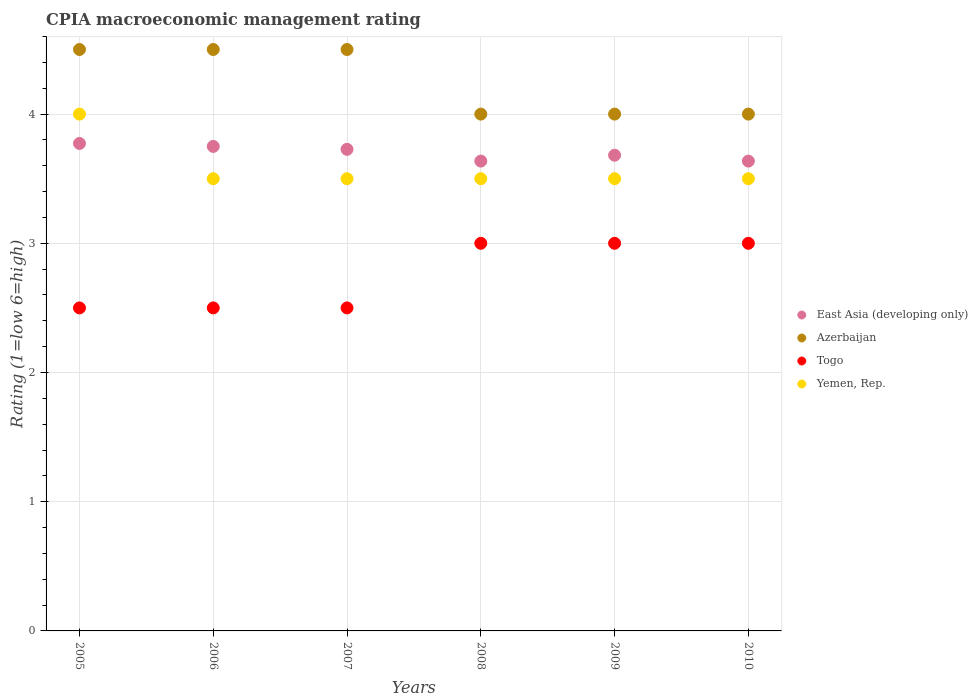How many different coloured dotlines are there?
Make the answer very short. 4. Is the number of dotlines equal to the number of legend labels?
Give a very brief answer. Yes. What is the CPIA rating in Togo in 2010?
Ensure brevity in your answer.  3. Across all years, what is the maximum CPIA rating in East Asia (developing only)?
Ensure brevity in your answer.  3.77. Across all years, what is the minimum CPIA rating in East Asia (developing only)?
Your answer should be very brief. 3.64. What is the average CPIA rating in Togo per year?
Ensure brevity in your answer.  2.75. In the year 2007, what is the difference between the CPIA rating in East Asia (developing only) and CPIA rating in Yemen, Rep.?
Your answer should be very brief. 0.23. What is the ratio of the CPIA rating in Yemen, Rep. in 2005 to that in 2006?
Provide a short and direct response. 1.14. Is the CPIA rating in East Asia (developing only) in 2006 less than that in 2007?
Make the answer very short. No. Is it the case that in every year, the sum of the CPIA rating in Azerbaijan and CPIA rating in Yemen, Rep.  is greater than the CPIA rating in Togo?
Offer a very short reply. Yes. Does the CPIA rating in Yemen, Rep. monotonically increase over the years?
Provide a short and direct response. No. Is the CPIA rating in East Asia (developing only) strictly less than the CPIA rating in Yemen, Rep. over the years?
Provide a succinct answer. No. How many years are there in the graph?
Your response must be concise. 6. What is the difference between two consecutive major ticks on the Y-axis?
Ensure brevity in your answer.  1. Does the graph contain any zero values?
Your answer should be very brief. No. Does the graph contain grids?
Your answer should be compact. Yes. How many legend labels are there?
Keep it short and to the point. 4. How are the legend labels stacked?
Ensure brevity in your answer.  Vertical. What is the title of the graph?
Offer a very short reply. CPIA macroeconomic management rating. What is the label or title of the X-axis?
Your answer should be very brief. Years. What is the Rating (1=low 6=high) of East Asia (developing only) in 2005?
Your answer should be compact. 3.77. What is the Rating (1=low 6=high) of Togo in 2005?
Your response must be concise. 2.5. What is the Rating (1=low 6=high) of East Asia (developing only) in 2006?
Offer a very short reply. 3.75. What is the Rating (1=low 6=high) of Azerbaijan in 2006?
Give a very brief answer. 4.5. What is the Rating (1=low 6=high) in Togo in 2006?
Make the answer very short. 2.5. What is the Rating (1=low 6=high) in East Asia (developing only) in 2007?
Your answer should be compact. 3.73. What is the Rating (1=low 6=high) in Togo in 2007?
Ensure brevity in your answer.  2.5. What is the Rating (1=low 6=high) in Yemen, Rep. in 2007?
Your response must be concise. 3.5. What is the Rating (1=low 6=high) of East Asia (developing only) in 2008?
Your answer should be compact. 3.64. What is the Rating (1=low 6=high) in Togo in 2008?
Provide a succinct answer. 3. What is the Rating (1=low 6=high) of Yemen, Rep. in 2008?
Provide a short and direct response. 3.5. What is the Rating (1=low 6=high) of East Asia (developing only) in 2009?
Provide a succinct answer. 3.68. What is the Rating (1=low 6=high) of Togo in 2009?
Offer a very short reply. 3. What is the Rating (1=low 6=high) in Yemen, Rep. in 2009?
Your response must be concise. 3.5. What is the Rating (1=low 6=high) in East Asia (developing only) in 2010?
Offer a very short reply. 3.64. What is the Rating (1=low 6=high) in Azerbaijan in 2010?
Give a very brief answer. 4. What is the Rating (1=low 6=high) of Togo in 2010?
Your answer should be very brief. 3. What is the Rating (1=low 6=high) in Yemen, Rep. in 2010?
Keep it short and to the point. 3.5. Across all years, what is the maximum Rating (1=low 6=high) of East Asia (developing only)?
Your answer should be compact. 3.77. Across all years, what is the maximum Rating (1=low 6=high) of Azerbaijan?
Your answer should be compact. 4.5. Across all years, what is the maximum Rating (1=low 6=high) of Togo?
Make the answer very short. 3. Across all years, what is the minimum Rating (1=low 6=high) in East Asia (developing only)?
Provide a short and direct response. 3.64. Across all years, what is the minimum Rating (1=low 6=high) of Togo?
Offer a terse response. 2.5. What is the total Rating (1=low 6=high) in East Asia (developing only) in the graph?
Make the answer very short. 22.2. What is the total Rating (1=low 6=high) in Azerbaijan in the graph?
Provide a succinct answer. 25.5. What is the total Rating (1=low 6=high) of Togo in the graph?
Your response must be concise. 16.5. What is the total Rating (1=low 6=high) in Yemen, Rep. in the graph?
Give a very brief answer. 21.5. What is the difference between the Rating (1=low 6=high) of East Asia (developing only) in 2005 and that in 2006?
Your answer should be very brief. 0.02. What is the difference between the Rating (1=low 6=high) in Togo in 2005 and that in 2006?
Offer a very short reply. 0. What is the difference between the Rating (1=low 6=high) in East Asia (developing only) in 2005 and that in 2007?
Keep it short and to the point. 0.05. What is the difference between the Rating (1=low 6=high) in Azerbaijan in 2005 and that in 2007?
Make the answer very short. 0. What is the difference between the Rating (1=low 6=high) of East Asia (developing only) in 2005 and that in 2008?
Offer a very short reply. 0.14. What is the difference between the Rating (1=low 6=high) in Azerbaijan in 2005 and that in 2008?
Your answer should be very brief. 0.5. What is the difference between the Rating (1=low 6=high) of East Asia (developing only) in 2005 and that in 2009?
Your answer should be compact. 0.09. What is the difference between the Rating (1=low 6=high) of Azerbaijan in 2005 and that in 2009?
Ensure brevity in your answer.  0.5. What is the difference between the Rating (1=low 6=high) in East Asia (developing only) in 2005 and that in 2010?
Your answer should be very brief. 0.14. What is the difference between the Rating (1=low 6=high) in Yemen, Rep. in 2005 and that in 2010?
Ensure brevity in your answer.  0.5. What is the difference between the Rating (1=low 6=high) of East Asia (developing only) in 2006 and that in 2007?
Your answer should be compact. 0.02. What is the difference between the Rating (1=low 6=high) in Yemen, Rep. in 2006 and that in 2007?
Ensure brevity in your answer.  0. What is the difference between the Rating (1=low 6=high) in East Asia (developing only) in 2006 and that in 2008?
Your answer should be compact. 0.11. What is the difference between the Rating (1=low 6=high) in Azerbaijan in 2006 and that in 2008?
Your answer should be very brief. 0.5. What is the difference between the Rating (1=low 6=high) in Togo in 2006 and that in 2008?
Provide a short and direct response. -0.5. What is the difference between the Rating (1=low 6=high) of Yemen, Rep. in 2006 and that in 2008?
Give a very brief answer. 0. What is the difference between the Rating (1=low 6=high) in East Asia (developing only) in 2006 and that in 2009?
Your answer should be compact. 0.07. What is the difference between the Rating (1=low 6=high) in Azerbaijan in 2006 and that in 2009?
Keep it short and to the point. 0.5. What is the difference between the Rating (1=low 6=high) of East Asia (developing only) in 2006 and that in 2010?
Your answer should be very brief. 0.11. What is the difference between the Rating (1=low 6=high) in Yemen, Rep. in 2006 and that in 2010?
Offer a very short reply. 0. What is the difference between the Rating (1=low 6=high) of East Asia (developing only) in 2007 and that in 2008?
Offer a very short reply. 0.09. What is the difference between the Rating (1=low 6=high) in Yemen, Rep. in 2007 and that in 2008?
Your response must be concise. 0. What is the difference between the Rating (1=low 6=high) of East Asia (developing only) in 2007 and that in 2009?
Provide a succinct answer. 0.05. What is the difference between the Rating (1=low 6=high) in Azerbaijan in 2007 and that in 2009?
Your answer should be compact. 0.5. What is the difference between the Rating (1=low 6=high) of Yemen, Rep. in 2007 and that in 2009?
Offer a very short reply. 0. What is the difference between the Rating (1=low 6=high) of East Asia (developing only) in 2007 and that in 2010?
Provide a short and direct response. 0.09. What is the difference between the Rating (1=low 6=high) of Azerbaijan in 2007 and that in 2010?
Give a very brief answer. 0.5. What is the difference between the Rating (1=low 6=high) of Yemen, Rep. in 2007 and that in 2010?
Offer a terse response. 0. What is the difference between the Rating (1=low 6=high) in East Asia (developing only) in 2008 and that in 2009?
Your answer should be very brief. -0.05. What is the difference between the Rating (1=low 6=high) in Azerbaijan in 2008 and that in 2009?
Make the answer very short. 0. What is the difference between the Rating (1=low 6=high) in Yemen, Rep. in 2008 and that in 2009?
Provide a succinct answer. 0. What is the difference between the Rating (1=low 6=high) in East Asia (developing only) in 2008 and that in 2010?
Offer a very short reply. 0. What is the difference between the Rating (1=low 6=high) of Yemen, Rep. in 2008 and that in 2010?
Make the answer very short. 0. What is the difference between the Rating (1=low 6=high) in East Asia (developing only) in 2009 and that in 2010?
Give a very brief answer. 0.05. What is the difference between the Rating (1=low 6=high) in Azerbaijan in 2009 and that in 2010?
Offer a terse response. 0. What is the difference between the Rating (1=low 6=high) of East Asia (developing only) in 2005 and the Rating (1=low 6=high) of Azerbaijan in 2006?
Provide a succinct answer. -0.73. What is the difference between the Rating (1=low 6=high) of East Asia (developing only) in 2005 and the Rating (1=low 6=high) of Togo in 2006?
Your answer should be compact. 1.27. What is the difference between the Rating (1=low 6=high) in East Asia (developing only) in 2005 and the Rating (1=low 6=high) in Yemen, Rep. in 2006?
Provide a succinct answer. 0.27. What is the difference between the Rating (1=low 6=high) in East Asia (developing only) in 2005 and the Rating (1=low 6=high) in Azerbaijan in 2007?
Give a very brief answer. -0.73. What is the difference between the Rating (1=low 6=high) of East Asia (developing only) in 2005 and the Rating (1=low 6=high) of Togo in 2007?
Provide a succinct answer. 1.27. What is the difference between the Rating (1=low 6=high) in East Asia (developing only) in 2005 and the Rating (1=low 6=high) in Yemen, Rep. in 2007?
Ensure brevity in your answer.  0.27. What is the difference between the Rating (1=low 6=high) in Togo in 2005 and the Rating (1=low 6=high) in Yemen, Rep. in 2007?
Keep it short and to the point. -1. What is the difference between the Rating (1=low 6=high) of East Asia (developing only) in 2005 and the Rating (1=low 6=high) of Azerbaijan in 2008?
Make the answer very short. -0.23. What is the difference between the Rating (1=low 6=high) of East Asia (developing only) in 2005 and the Rating (1=low 6=high) of Togo in 2008?
Offer a very short reply. 0.77. What is the difference between the Rating (1=low 6=high) in East Asia (developing only) in 2005 and the Rating (1=low 6=high) in Yemen, Rep. in 2008?
Provide a succinct answer. 0.27. What is the difference between the Rating (1=low 6=high) of Azerbaijan in 2005 and the Rating (1=low 6=high) of Yemen, Rep. in 2008?
Give a very brief answer. 1. What is the difference between the Rating (1=low 6=high) in East Asia (developing only) in 2005 and the Rating (1=low 6=high) in Azerbaijan in 2009?
Ensure brevity in your answer.  -0.23. What is the difference between the Rating (1=low 6=high) of East Asia (developing only) in 2005 and the Rating (1=low 6=high) of Togo in 2009?
Ensure brevity in your answer.  0.77. What is the difference between the Rating (1=low 6=high) in East Asia (developing only) in 2005 and the Rating (1=low 6=high) in Yemen, Rep. in 2009?
Your answer should be very brief. 0.27. What is the difference between the Rating (1=low 6=high) of Azerbaijan in 2005 and the Rating (1=low 6=high) of Togo in 2009?
Your answer should be compact. 1.5. What is the difference between the Rating (1=low 6=high) in East Asia (developing only) in 2005 and the Rating (1=low 6=high) in Azerbaijan in 2010?
Keep it short and to the point. -0.23. What is the difference between the Rating (1=low 6=high) of East Asia (developing only) in 2005 and the Rating (1=low 6=high) of Togo in 2010?
Your answer should be compact. 0.77. What is the difference between the Rating (1=low 6=high) in East Asia (developing only) in 2005 and the Rating (1=low 6=high) in Yemen, Rep. in 2010?
Keep it short and to the point. 0.27. What is the difference between the Rating (1=low 6=high) of Azerbaijan in 2005 and the Rating (1=low 6=high) of Togo in 2010?
Provide a succinct answer. 1.5. What is the difference between the Rating (1=low 6=high) in Azerbaijan in 2005 and the Rating (1=low 6=high) in Yemen, Rep. in 2010?
Make the answer very short. 1. What is the difference between the Rating (1=low 6=high) in East Asia (developing only) in 2006 and the Rating (1=low 6=high) in Azerbaijan in 2007?
Provide a short and direct response. -0.75. What is the difference between the Rating (1=low 6=high) of East Asia (developing only) in 2006 and the Rating (1=low 6=high) of Yemen, Rep. in 2007?
Keep it short and to the point. 0.25. What is the difference between the Rating (1=low 6=high) of Azerbaijan in 2006 and the Rating (1=low 6=high) of Togo in 2007?
Provide a short and direct response. 2. What is the difference between the Rating (1=low 6=high) in Togo in 2006 and the Rating (1=low 6=high) in Yemen, Rep. in 2007?
Offer a terse response. -1. What is the difference between the Rating (1=low 6=high) in East Asia (developing only) in 2006 and the Rating (1=low 6=high) in Togo in 2008?
Provide a succinct answer. 0.75. What is the difference between the Rating (1=low 6=high) in East Asia (developing only) in 2006 and the Rating (1=low 6=high) in Yemen, Rep. in 2008?
Provide a short and direct response. 0.25. What is the difference between the Rating (1=low 6=high) in East Asia (developing only) in 2006 and the Rating (1=low 6=high) in Yemen, Rep. in 2009?
Give a very brief answer. 0.25. What is the difference between the Rating (1=low 6=high) in Azerbaijan in 2006 and the Rating (1=low 6=high) in Yemen, Rep. in 2009?
Your answer should be compact. 1. What is the difference between the Rating (1=low 6=high) in East Asia (developing only) in 2006 and the Rating (1=low 6=high) in Azerbaijan in 2010?
Offer a terse response. -0.25. What is the difference between the Rating (1=low 6=high) in East Asia (developing only) in 2006 and the Rating (1=low 6=high) in Togo in 2010?
Make the answer very short. 0.75. What is the difference between the Rating (1=low 6=high) in East Asia (developing only) in 2006 and the Rating (1=low 6=high) in Yemen, Rep. in 2010?
Offer a very short reply. 0.25. What is the difference between the Rating (1=low 6=high) of Azerbaijan in 2006 and the Rating (1=low 6=high) of Togo in 2010?
Keep it short and to the point. 1.5. What is the difference between the Rating (1=low 6=high) of Azerbaijan in 2006 and the Rating (1=low 6=high) of Yemen, Rep. in 2010?
Your response must be concise. 1. What is the difference between the Rating (1=low 6=high) in Togo in 2006 and the Rating (1=low 6=high) in Yemen, Rep. in 2010?
Provide a short and direct response. -1. What is the difference between the Rating (1=low 6=high) of East Asia (developing only) in 2007 and the Rating (1=low 6=high) of Azerbaijan in 2008?
Your response must be concise. -0.27. What is the difference between the Rating (1=low 6=high) in East Asia (developing only) in 2007 and the Rating (1=low 6=high) in Togo in 2008?
Provide a succinct answer. 0.73. What is the difference between the Rating (1=low 6=high) of East Asia (developing only) in 2007 and the Rating (1=low 6=high) of Yemen, Rep. in 2008?
Your answer should be very brief. 0.23. What is the difference between the Rating (1=low 6=high) in Azerbaijan in 2007 and the Rating (1=low 6=high) in Yemen, Rep. in 2008?
Your response must be concise. 1. What is the difference between the Rating (1=low 6=high) of Togo in 2007 and the Rating (1=low 6=high) of Yemen, Rep. in 2008?
Offer a very short reply. -1. What is the difference between the Rating (1=low 6=high) of East Asia (developing only) in 2007 and the Rating (1=low 6=high) of Azerbaijan in 2009?
Offer a terse response. -0.27. What is the difference between the Rating (1=low 6=high) in East Asia (developing only) in 2007 and the Rating (1=low 6=high) in Togo in 2009?
Your response must be concise. 0.73. What is the difference between the Rating (1=low 6=high) in East Asia (developing only) in 2007 and the Rating (1=low 6=high) in Yemen, Rep. in 2009?
Give a very brief answer. 0.23. What is the difference between the Rating (1=low 6=high) in Azerbaijan in 2007 and the Rating (1=low 6=high) in Togo in 2009?
Provide a succinct answer. 1.5. What is the difference between the Rating (1=low 6=high) in Togo in 2007 and the Rating (1=low 6=high) in Yemen, Rep. in 2009?
Your response must be concise. -1. What is the difference between the Rating (1=low 6=high) in East Asia (developing only) in 2007 and the Rating (1=low 6=high) in Azerbaijan in 2010?
Give a very brief answer. -0.27. What is the difference between the Rating (1=low 6=high) in East Asia (developing only) in 2007 and the Rating (1=low 6=high) in Togo in 2010?
Provide a short and direct response. 0.73. What is the difference between the Rating (1=low 6=high) of East Asia (developing only) in 2007 and the Rating (1=low 6=high) of Yemen, Rep. in 2010?
Keep it short and to the point. 0.23. What is the difference between the Rating (1=low 6=high) of Azerbaijan in 2007 and the Rating (1=low 6=high) of Togo in 2010?
Your answer should be compact. 1.5. What is the difference between the Rating (1=low 6=high) in East Asia (developing only) in 2008 and the Rating (1=low 6=high) in Azerbaijan in 2009?
Provide a short and direct response. -0.36. What is the difference between the Rating (1=low 6=high) in East Asia (developing only) in 2008 and the Rating (1=low 6=high) in Togo in 2009?
Make the answer very short. 0.64. What is the difference between the Rating (1=low 6=high) in East Asia (developing only) in 2008 and the Rating (1=low 6=high) in Yemen, Rep. in 2009?
Ensure brevity in your answer.  0.14. What is the difference between the Rating (1=low 6=high) of Azerbaijan in 2008 and the Rating (1=low 6=high) of Togo in 2009?
Provide a succinct answer. 1. What is the difference between the Rating (1=low 6=high) in Togo in 2008 and the Rating (1=low 6=high) in Yemen, Rep. in 2009?
Provide a succinct answer. -0.5. What is the difference between the Rating (1=low 6=high) in East Asia (developing only) in 2008 and the Rating (1=low 6=high) in Azerbaijan in 2010?
Your answer should be very brief. -0.36. What is the difference between the Rating (1=low 6=high) in East Asia (developing only) in 2008 and the Rating (1=low 6=high) in Togo in 2010?
Keep it short and to the point. 0.64. What is the difference between the Rating (1=low 6=high) of East Asia (developing only) in 2008 and the Rating (1=low 6=high) of Yemen, Rep. in 2010?
Offer a very short reply. 0.14. What is the difference between the Rating (1=low 6=high) of Azerbaijan in 2008 and the Rating (1=low 6=high) of Togo in 2010?
Ensure brevity in your answer.  1. What is the difference between the Rating (1=low 6=high) of Togo in 2008 and the Rating (1=low 6=high) of Yemen, Rep. in 2010?
Offer a very short reply. -0.5. What is the difference between the Rating (1=low 6=high) in East Asia (developing only) in 2009 and the Rating (1=low 6=high) in Azerbaijan in 2010?
Your response must be concise. -0.32. What is the difference between the Rating (1=low 6=high) of East Asia (developing only) in 2009 and the Rating (1=low 6=high) of Togo in 2010?
Your response must be concise. 0.68. What is the difference between the Rating (1=low 6=high) in East Asia (developing only) in 2009 and the Rating (1=low 6=high) in Yemen, Rep. in 2010?
Ensure brevity in your answer.  0.18. What is the difference between the Rating (1=low 6=high) in Azerbaijan in 2009 and the Rating (1=low 6=high) in Togo in 2010?
Your answer should be very brief. 1. What is the difference between the Rating (1=low 6=high) of Azerbaijan in 2009 and the Rating (1=low 6=high) of Yemen, Rep. in 2010?
Make the answer very short. 0.5. What is the average Rating (1=low 6=high) of East Asia (developing only) per year?
Provide a short and direct response. 3.7. What is the average Rating (1=low 6=high) in Azerbaijan per year?
Offer a very short reply. 4.25. What is the average Rating (1=low 6=high) of Togo per year?
Your answer should be compact. 2.75. What is the average Rating (1=low 6=high) of Yemen, Rep. per year?
Give a very brief answer. 3.58. In the year 2005, what is the difference between the Rating (1=low 6=high) of East Asia (developing only) and Rating (1=low 6=high) of Azerbaijan?
Your answer should be compact. -0.73. In the year 2005, what is the difference between the Rating (1=low 6=high) of East Asia (developing only) and Rating (1=low 6=high) of Togo?
Keep it short and to the point. 1.27. In the year 2005, what is the difference between the Rating (1=low 6=high) of East Asia (developing only) and Rating (1=low 6=high) of Yemen, Rep.?
Your answer should be very brief. -0.23. In the year 2005, what is the difference between the Rating (1=low 6=high) of Togo and Rating (1=low 6=high) of Yemen, Rep.?
Offer a terse response. -1.5. In the year 2006, what is the difference between the Rating (1=low 6=high) in East Asia (developing only) and Rating (1=low 6=high) in Azerbaijan?
Your answer should be very brief. -0.75. In the year 2006, what is the difference between the Rating (1=low 6=high) of East Asia (developing only) and Rating (1=low 6=high) of Togo?
Provide a succinct answer. 1.25. In the year 2006, what is the difference between the Rating (1=low 6=high) in East Asia (developing only) and Rating (1=low 6=high) in Yemen, Rep.?
Ensure brevity in your answer.  0.25. In the year 2006, what is the difference between the Rating (1=low 6=high) of Azerbaijan and Rating (1=low 6=high) of Togo?
Make the answer very short. 2. In the year 2006, what is the difference between the Rating (1=low 6=high) in Azerbaijan and Rating (1=low 6=high) in Yemen, Rep.?
Offer a very short reply. 1. In the year 2007, what is the difference between the Rating (1=low 6=high) in East Asia (developing only) and Rating (1=low 6=high) in Azerbaijan?
Give a very brief answer. -0.77. In the year 2007, what is the difference between the Rating (1=low 6=high) of East Asia (developing only) and Rating (1=low 6=high) of Togo?
Ensure brevity in your answer.  1.23. In the year 2007, what is the difference between the Rating (1=low 6=high) in East Asia (developing only) and Rating (1=low 6=high) in Yemen, Rep.?
Provide a short and direct response. 0.23. In the year 2007, what is the difference between the Rating (1=low 6=high) in Azerbaijan and Rating (1=low 6=high) in Togo?
Your answer should be very brief. 2. In the year 2007, what is the difference between the Rating (1=low 6=high) of Azerbaijan and Rating (1=low 6=high) of Yemen, Rep.?
Provide a succinct answer. 1. In the year 2007, what is the difference between the Rating (1=low 6=high) in Togo and Rating (1=low 6=high) in Yemen, Rep.?
Your response must be concise. -1. In the year 2008, what is the difference between the Rating (1=low 6=high) in East Asia (developing only) and Rating (1=low 6=high) in Azerbaijan?
Your answer should be very brief. -0.36. In the year 2008, what is the difference between the Rating (1=low 6=high) of East Asia (developing only) and Rating (1=low 6=high) of Togo?
Your answer should be very brief. 0.64. In the year 2008, what is the difference between the Rating (1=low 6=high) of East Asia (developing only) and Rating (1=low 6=high) of Yemen, Rep.?
Offer a terse response. 0.14. In the year 2008, what is the difference between the Rating (1=low 6=high) in Azerbaijan and Rating (1=low 6=high) in Yemen, Rep.?
Keep it short and to the point. 0.5. In the year 2008, what is the difference between the Rating (1=low 6=high) of Togo and Rating (1=low 6=high) of Yemen, Rep.?
Make the answer very short. -0.5. In the year 2009, what is the difference between the Rating (1=low 6=high) of East Asia (developing only) and Rating (1=low 6=high) of Azerbaijan?
Ensure brevity in your answer.  -0.32. In the year 2009, what is the difference between the Rating (1=low 6=high) of East Asia (developing only) and Rating (1=low 6=high) of Togo?
Make the answer very short. 0.68. In the year 2009, what is the difference between the Rating (1=low 6=high) of East Asia (developing only) and Rating (1=low 6=high) of Yemen, Rep.?
Your response must be concise. 0.18. In the year 2009, what is the difference between the Rating (1=low 6=high) in Azerbaijan and Rating (1=low 6=high) in Yemen, Rep.?
Make the answer very short. 0.5. In the year 2010, what is the difference between the Rating (1=low 6=high) of East Asia (developing only) and Rating (1=low 6=high) of Azerbaijan?
Give a very brief answer. -0.36. In the year 2010, what is the difference between the Rating (1=low 6=high) of East Asia (developing only) and Rating (1=low 6=high) of Togo?
Offer a terse response. 0.64. In the year 2010, what is the difference between the Rating (1=low 6=high) in East Asia (developing only) and Rating (1=low 6=high) in Yemen, Rep.?
Ensure brevity in your answer.  0.14. In the year 2010, what is the difference between the Rating (1=low 6=high) in Azerbaijan and Rating (1=low 6=high) in Yemen, Rep.?
Give a very brief answer. 0.5. In the year 2010, what is the difference between the Rating (1=low 6=high) in Togo and Rating (1=low 6=high) in Yemen, Rep.?
Offer a terse response. -0.5. What is the ratio of the Rating (1=low 6=high) of East Asia (developing only) in 2005 to that in 2006?
Offer a very short reply. 1.01. What is the ratio of the Rating (1=low 6=high) of Azerbaijan in 2005 to that in 2006?
Your response must be concise. 1. What is the ratio of the Rating (1=low 6=high) in East Asia (developing only) in 2005 to that in 2007?
Your answer should be very brief. 1.01. What is the ratio of the Rating (1=low 6=high) in Azerbaijan in 2005 to that in 2007?
Make the answer very short. 1. What is the ratio of the Rating (1=low 6=high) of Togo in 2005 to that in 2007?
Make the answer very short. 1. What is the ratio of the Rating (1=low 6=high) in East Asia (developing only) in 2005 to that in 2008?
Keep it short and to the point. 1.04. What is the ratio of the Rating (1=low 6=high) of Yemen, Rep. in 2005 to that in 2008?
Give a very brief answer. 1.14. What is the ratio of the Rating (1=low 6=high) in East Asia (developing only) in 2005 to that in 2009?
Offer a very short reply. 1.02. What is the ratio of the Rating (1=low 6=high) of Yemen, Rep. in 2005 to that in 2009?
Your answer should be very brief. 1.14. What is the ratio of the Rating (1=low 6=high) in East Asia (developing only) in 2005 to that in 2010?
Make the answer very short. 1.04. What is the ratio of the Rating (1=low 6=high) in Azerbaijan in 2005 to that in 2010?
Ensure brevity in your answer.  1.12. What is the ratio of the Rating (1=low 6=high) in Togo in 2005 to that in 2010?
Offer a terse response. 0.83. What is the ratio of the Rating (1=low 6=high) of Togo in 2006 to that in 2007?
Your response must be concise. 1. What is the ratio of the Rating (1=low 6=high) in East Asia (developing only) in 2006 to that in 2008?
Provide a short and direct response. 1.03. What is the ratio of the Rating (1=low 6=high) in Azerbaijan in 2006 to that in 2008?
Keep it short and to the point. 1.12. What is the ratio of the Rating (1=low 6=high) of Yemen, Rep. in 2006 to that in 2008?
Provide a short and direct response. 1. What is the ratio of the Rating (1=low 6=high) in East Asia (developing only) in 2006 to that in 2009?
Ensure brevity in your answer.  1.02. What is the ratio of the Rating (1=low 6=high) in Azerbaijan in 2006 to that in 2009?
Keep it short and to the point. 1.12. What is the ratio of the Rating (1=low 6=high) of Yemen, Rep. in 2006 to that in 2009?
Offer a very short reply. 1. What is the ratio of the Rating (1=low 6=high) of East Asia (developing only) in 2006 to that in 2010?
Keep it short and to the point. 1.03. What is the ratio of the Rating (1=low 6=high) in Togo in 2006 to that in 2010?
Make the answer very short. 0.83. What is the ratio of the Rating (1=low 6=high) in Yemen, Rep. in 2006 to that in 2010?
Provide a short and direct response. 1. What is the ratio of the Rating (1=low 6=high) of East Asia (developing only) in 2007 to that in 2008?
Your answer should be very brief. 1.02. What is the ratio of the Rating (1=low 6=high) of Azerbaijan in 2007 to that in 2008?
Provide a short and direct response. 1.12. What is the ratio of the Rating (1=low 6=high) of East Asia (developing only) in 2007 to that in 2009?
Make the answer very short. 1.01. What is the ratio of the Rating (1=low 6=high) in East Asia (developing only) in 2007 to that in 2010?
Your answer should be very brief. 1.02. What is the ratio of the Rating (1=low 6=high) of Togo in 2007 to that in 2010?
Provide a succinct answer. 0.83. What is the ratio of the Rating (1=low 6=high) of Yemen, Rep. in 2007 to that in 2010?
Make the answer very short. 1. What is the ratio of the Rating (1=low 6=high) of Azerbaijan in 2008 to that in 2009?
Offer a terse response. 1. What is the ratio of the Rating (1=low 6=high) of Togo in 2008 to that in 2009?
Give a very brief answer. 1. What is the ratio of the Rating (1=low 6=high) in East Asia (developing only) in 2008 to that in 2010?
Provide a short and direct response. 1. What is the ratio of the Rating (1=low 6=high) in East Asia (developing only) in 2009 to that in 2010?
Provide a short and direct response. 1.01. What is the ratio of the Rating (1=low 6=high) in Togo in 2009 to that in 2010?
Make the answer very short. 1. What is the difference between the highest and the second highest Rating (1=low 6=high) in East Asia (developing only)?
Your response must be concise. 0.02. What is the difference between the highest and the second highest Rating (1=low 6=high) in Azerbaijan?
Your response must be concise. 0. What is the difference between the highest and the lowest Rating (1=low 6=high) of East Asia (developing only)?
Provide a short and direct response. 0.14. What is the difference between the highest and the lowest Rating (1=low 6=high) in Azerbaijan?
Your answer should be very brief. 0.5. What is the difference between the highest and the lowest Rating (1=low 6=high) in Togo?
Keep it short and to the point. 0.5. What is the difference between the highest and the lowest Rating (1=low 6=high) in Yemen, Rep.?
Give a very brief answer. 0.5. 